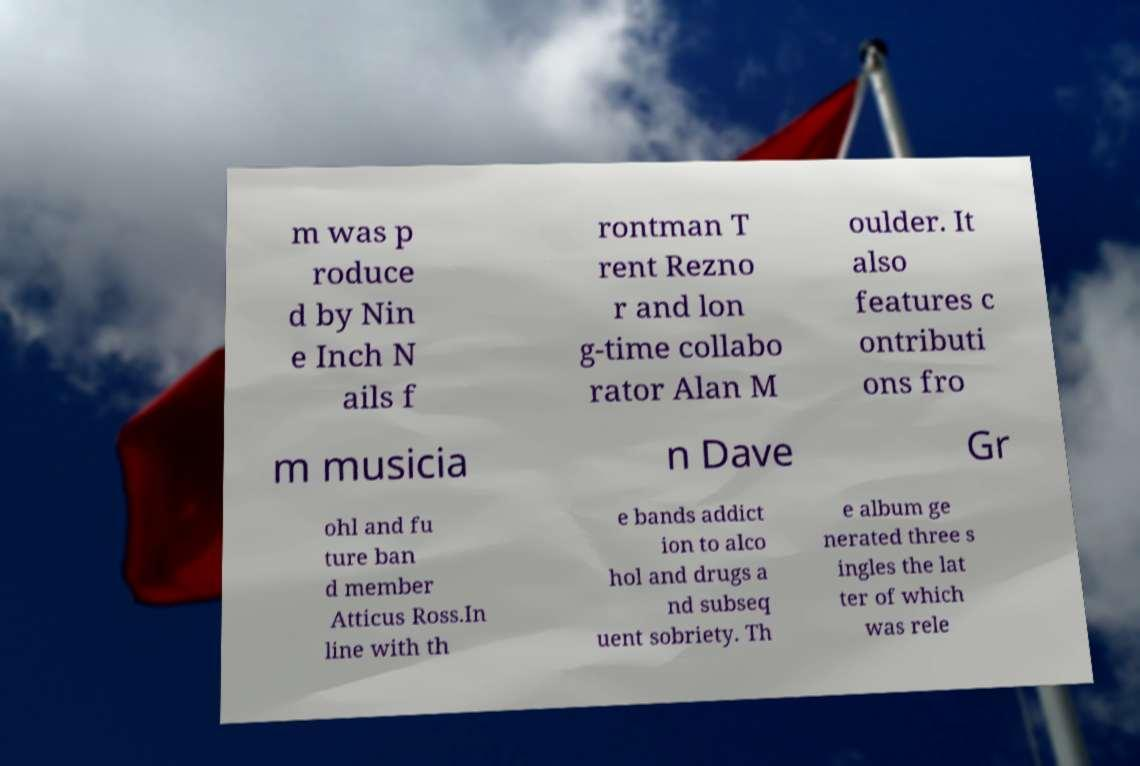Can you read and provide the text displayed in the image?This photo seems to have some interesting text. Can you extract and type it out for me? m was p roduce d by Nin e Inch N ails f rontman T rent Rezno r and lon g-time collabo rator Alan M oulder. It also features c ontributi ons fro m musicia n Dave Gr ohl and fu ture ban d member Atticus Ross.In line with th e bands addict ion to alco hol and drugs a nd subseq uent sobriety. Th e album ge nerated three s ingles the lat ter of which was rele 